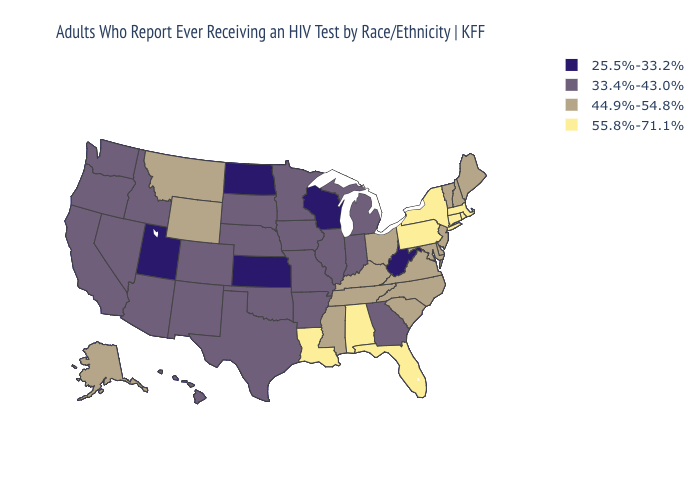Name the states that have a value in the range 44.9%-54.8%?
Write a very short answer. Alaska, Delaware, Kentucky, Maine, Maryland, Mississippi, Montana, New Hampshire, New Jersey, North Carolina, Ohio, South Carolina, Tennessee, Vermont, Virginia, Wyoming. What is the value of South Dakota?
Keep it brief. 33.4%-43.0%. Does Ohio have the highest value in the MidWest?
Answer briefly. Yes. Does the first symbol in the legend represent the smallest category?
Answer briefly. Yes. Which states have the lowest value in the South?
Give a very brief answer. West Virginia. Which states have the highest value in the USA?
Quick response, please. Alabama, Connecticut, Florida, Louisiana, Massachusetts, New York, Pennsylvania, Rhode Island. Which states have the lowest value in the USA?
Short answer required. Kansas, North Dakota, Utah, West Virginia, Wisconsin. Among the states that border Texas , does Louisiana have the highest value?
Concise answer only. Yes. What is the lowest value in the MidWest?
Write a very short answer. 25.5%-33.2%. What is the highest value in the USA?
Be succinct. 55.8%-71.1%. What is the value of Nebraska?
Be succinct. 33.4%-43.0%. What is the highest value in the USA?
Short answer required. 55.8%-71.1%. What is the value of Kentucky?
Answer briefly. 44.9%-54.8%. Which states have the lowest value in the USA?
Short answer required. Kansas, North Dakota, Utah, West Virginia, Wisconsin. 